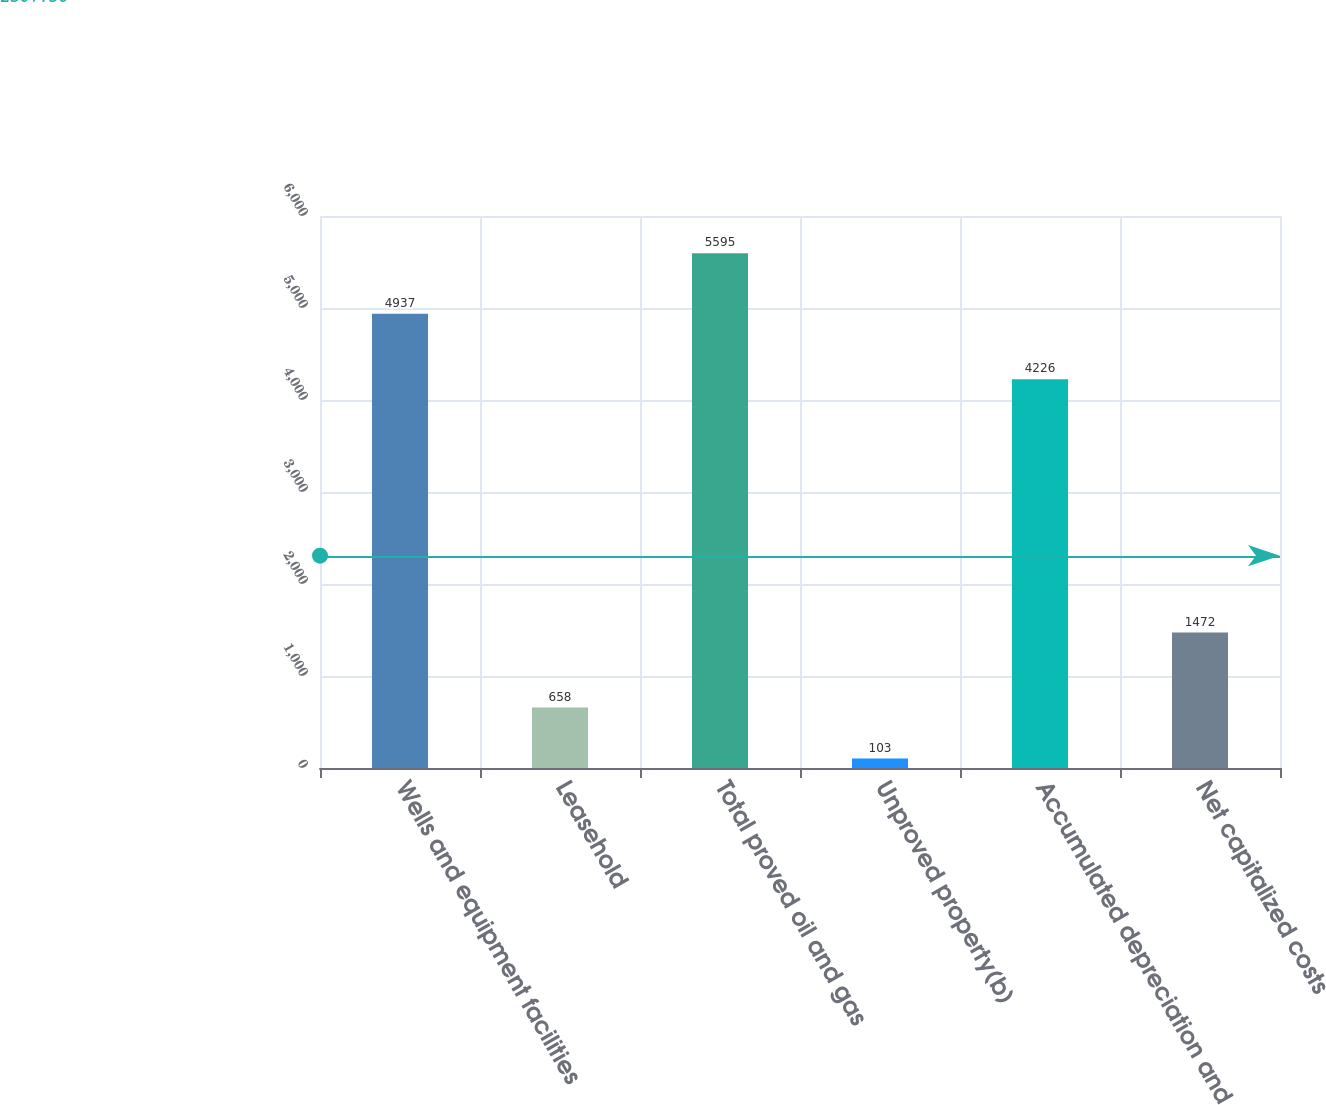Convert chart. <chart><loc_0><loc_0><loc_500><loc_500><bar_chart><fcel>Wells and equipment facilities<fcel>Leasehold<fcel>Total proved oil and gas<fcel>Unproved property(b)<fcel>Accumulated depreciation and<fcel>Net capitalized costs<nl><fcel>4937<fcel>658<fcel>5595<fcel>103<fcel>4226<fcel>1472<nl></chart> 